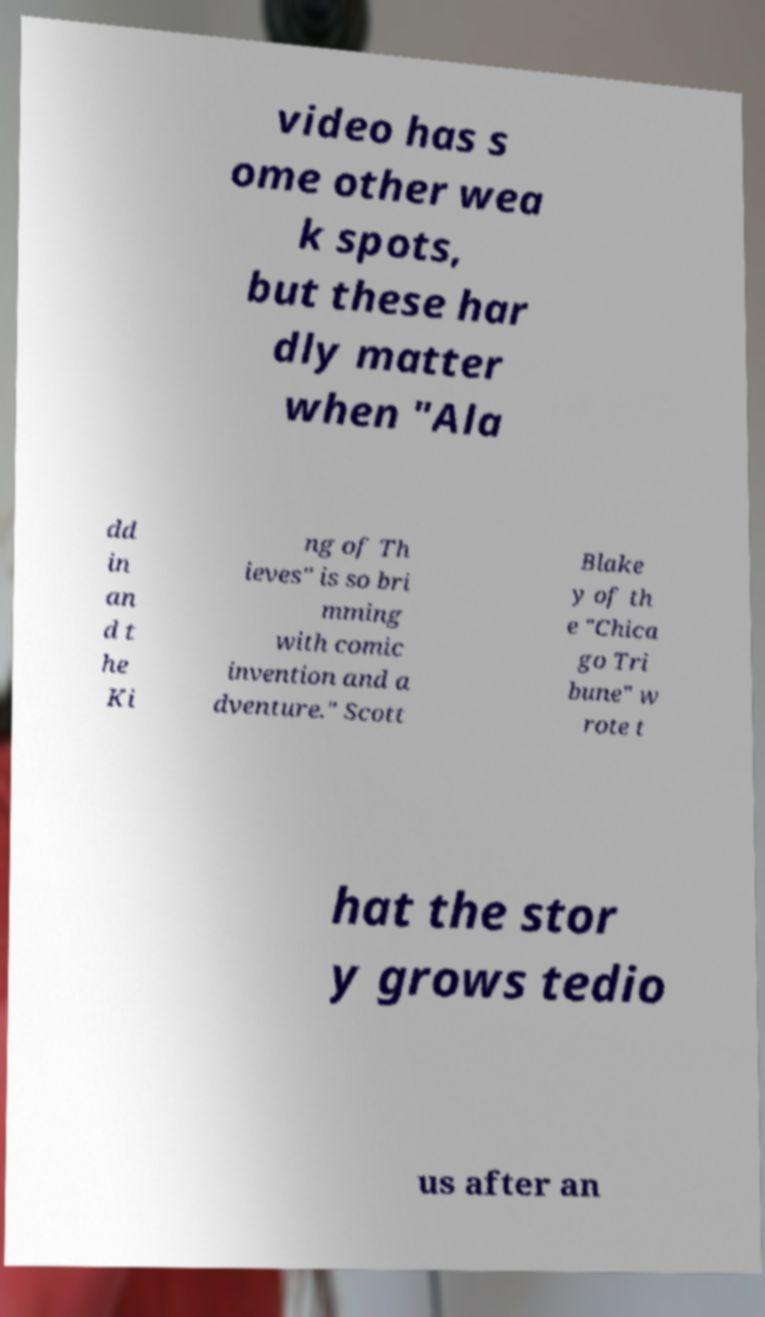Can you accurately transcribe the text from the provided image for me? video has s ome other wea k spots, but these har dly matter when "Ala dd in an d t he Ki ng of Th ieves" is so bri mming with comic invention and a dventure." Scott Blake y of th e "Chica go Tri bune" w rote t hat the stor y grows tedio us after an 